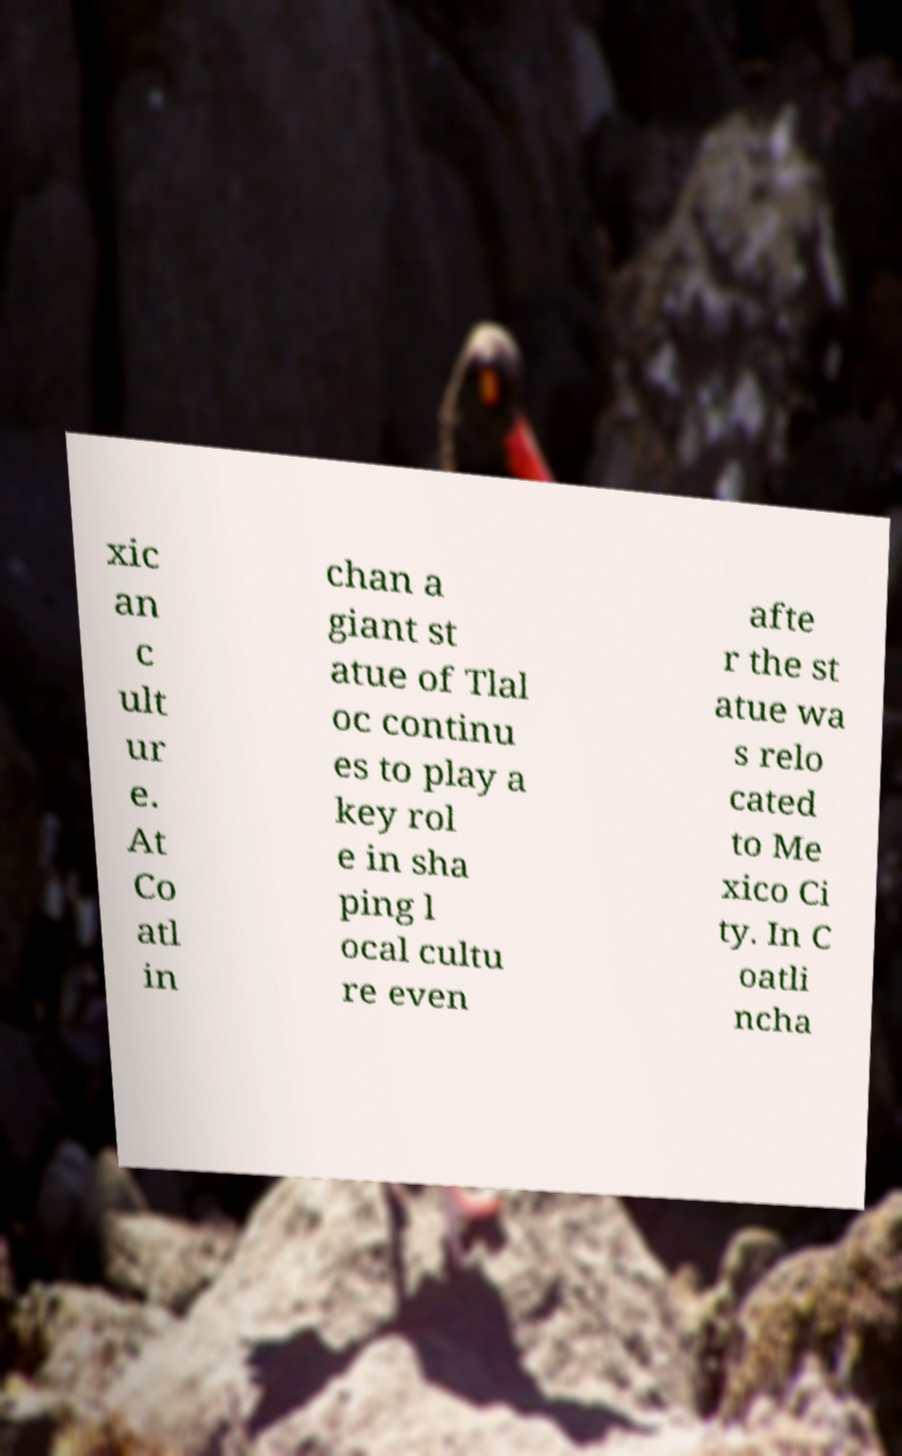Please read and relay the text visible in this image. What does it say? xic an c ult ur e. At Co atl in chan a giant st atue of Tlal oc continu es to play a key rol e in sha ping l ocal cultu re even afte r the st atue wa s relo cated to Me xico Ci ty. In C oatli ncha 